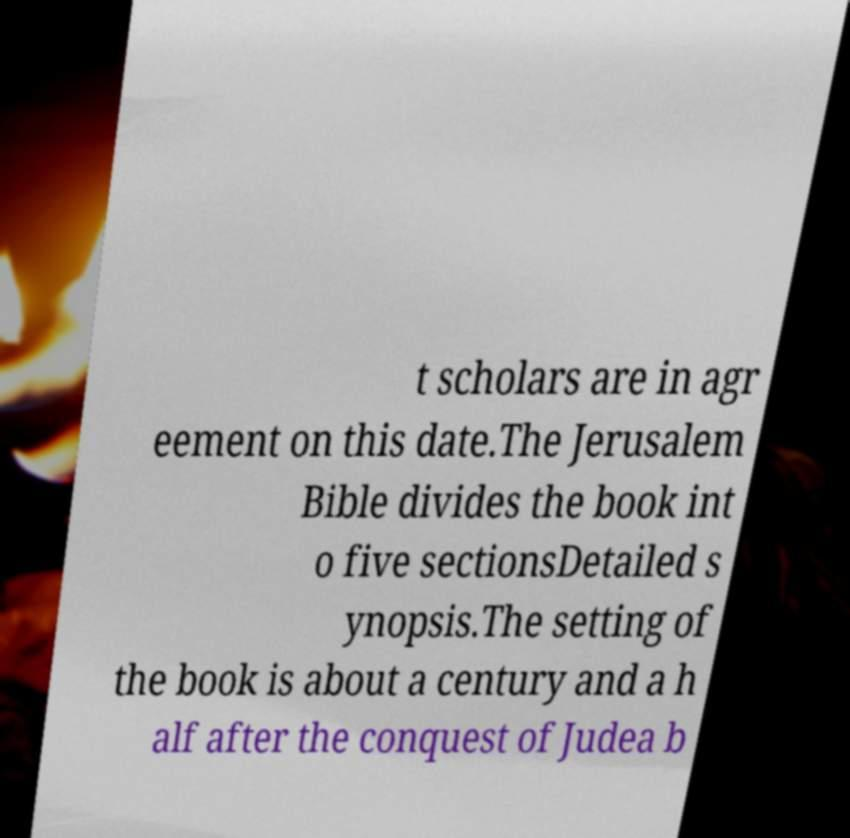Please identify and transcribe the text found in this image. t scholars are in agr eement on this date.The Jerusalem Bible divides the book int o five sectionsDetailed s ynopsis.The setting of the book is about a century and a h alf after the conquest of Judea b 